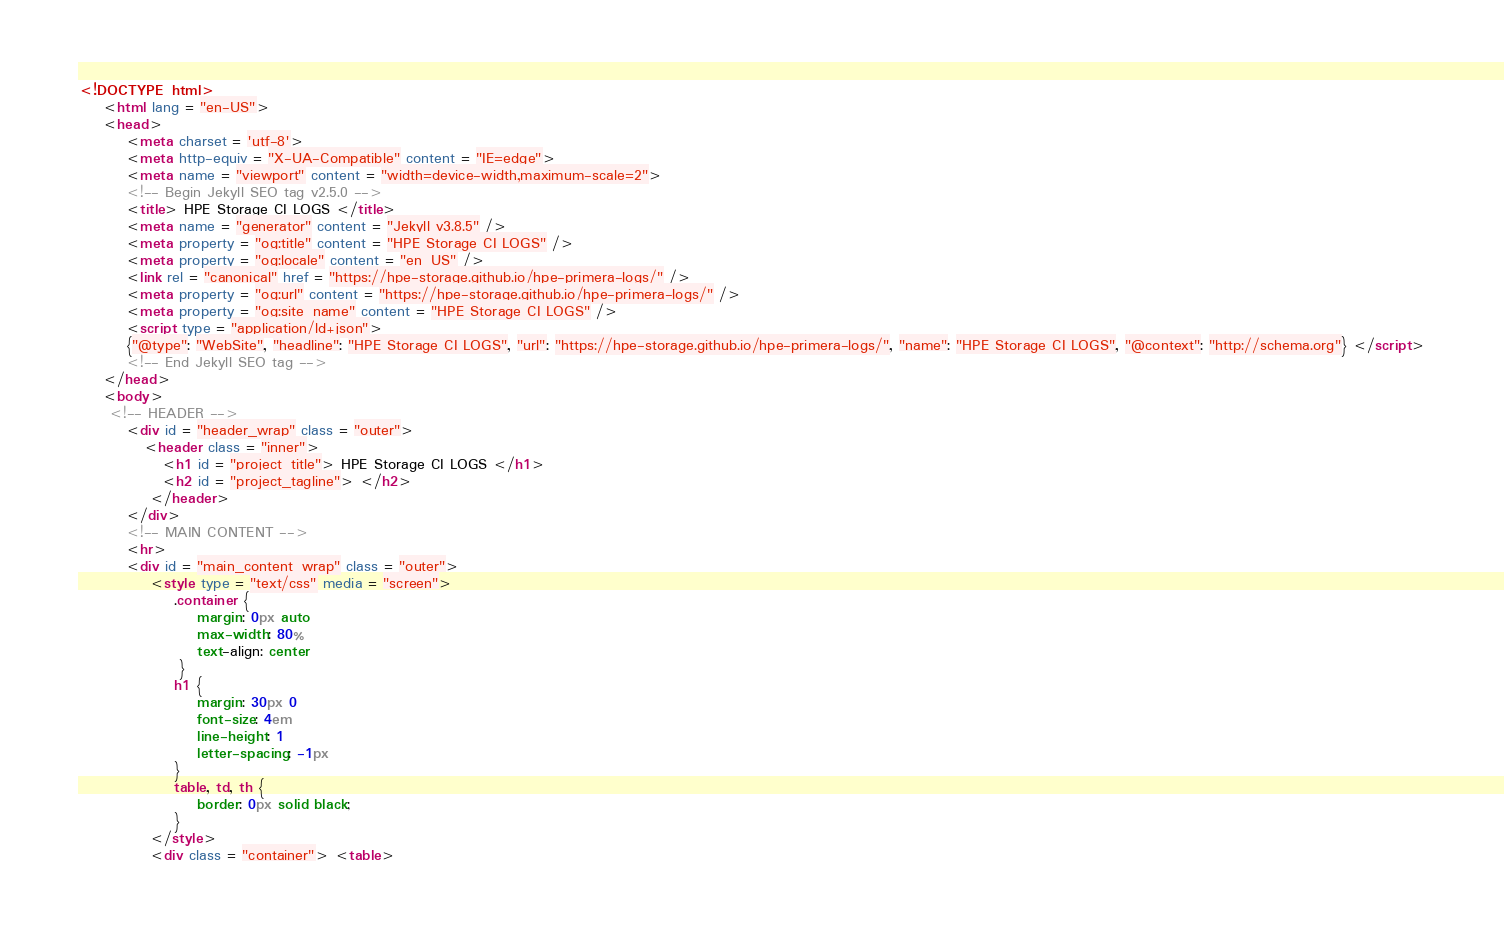Convert code to text. <code><loc_0><loc_0><loc_500><loc_500><_HTML_>
<!DOCTYPE html>
    <html lang = "en-US">
    <head>
        <meta charset = 'utf-8'>
        <meta http-equiv = "X-UA-Compatible" content = "IE=edge">
        <meta name = "viewport" content = "width=device-width,maximum-scale=2">
        <!-- Begin Jekyll SEO tag v2.5.0 -->
        <title> HPE Storage CI LOGS </title>
        <meta name = "generator" content = "Jekyll v3.8.5" />
        <meta property = "og:title" content = "HPE Storage CI LOGS" />
        <meta property = "og:locale" content = "en_US" />
        <link rel = "canonical" href = "https://hpe-storage.github.io/hpe-primera-logs/" />
        <meta property = "og:url" content = "https://hpe-storage.github.io/hpe-primera-logs/" />
        <meta property = "og:site_name" content = "HPE Storage CI LOGS" />
        <script type = "application/ld+json">
        {"@type": "WebSite", "headline": "HPE Storage CI LOGS", "url": "https://hpe-storage.github.io/hpe-primera-logs/", "name": "HPE Storage CI LOGS", "@context": "http://schema.org"} </script>
        <!-- End Jekyll SEO tag -->
    </head>
    <body>
     <!-- HEADER -->
        <div id = "header_wrap" class = "outer">
           <header class = "inner">
              <h1 id = "project_title"> HPE Storage CI LOGS </h1>
              <h2 id = "project_tagline"> </h2>
            </header>
        </div>
        <!-- MAIN CONTENT -->
        <hr>
        <div id = "main_content_wrap" class = "outer">
            <style type = "text/css" media = "screen">
                .container {
                    margin: 0px auto
                    max-width: 80%
                    text-align: center
                 }
                h1 {
                    margin: 30px 0
                    font-size: 4em
                    line-height: 1
                    letter-spacing: -1px
                }
                table, td, th {
                    border: 0px solid black;
                }
            </style>
            <div class = "container"> <table></code> 